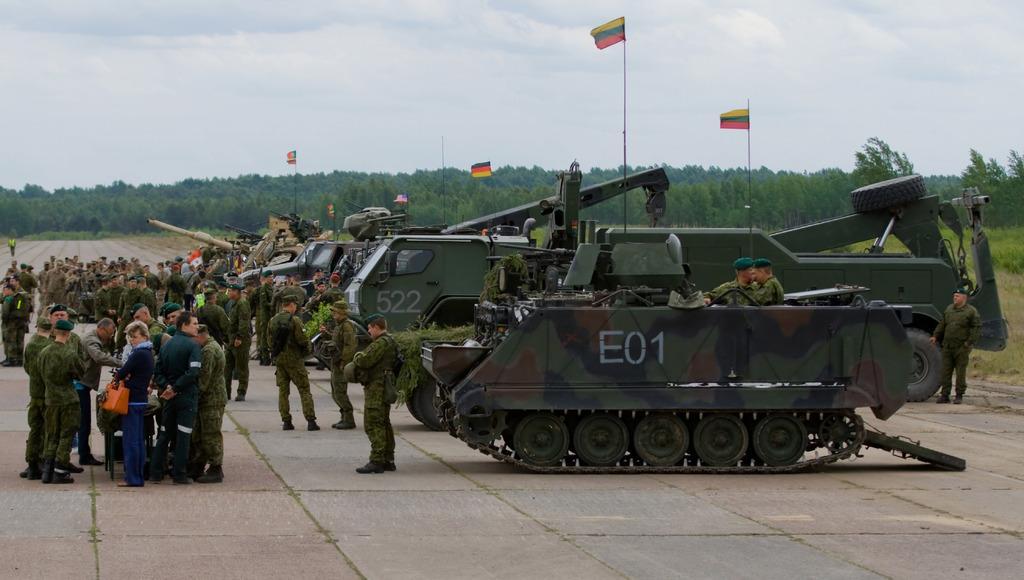Could you give a brief overview of what you see in this image? In this image there are some persons standing on the left side of this image and there are some machinery on the right side of this image. There are some trees in the background. There is one person standing on the right side of this image and there are two persons sitting in to this vehicle. There is a sky on the top of this image. 